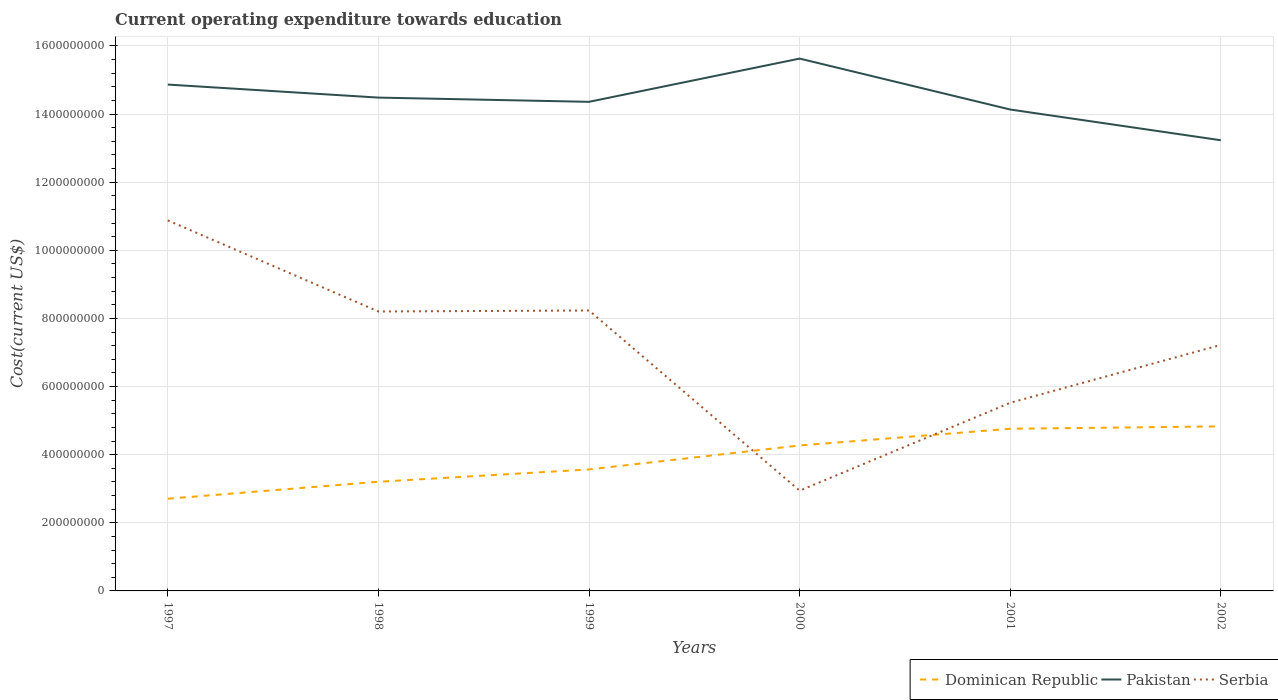Across all years, what is the maximum expenditure towards education in Serbia?
Ensure brevity in your answer.  2.94e+08. What is the total expenditure towards education in Pakistan in the graph?
Make the answer very short. 2.40e+08. What is the difference between the highest and the second highest expenditure towards education in Pakistan?
Make the answer very short. 2.40e+08. Is the expenditure towards education in Pakistan strictly greater than the expenditure towards education in Dominican Republic over the years?
Keep it short and to the point. No. How many years are there in the graph?
Give a very brief answer. 6. What is the difference between two consecutive major ticks on the Y-axis?
Keep it short and to the point. 2.00e+08. Are the values on the major ticks of Y-axis written in scientific E-notation?
Your answer should be very brief. No. Does the graph contain any zero values?
Offer a terse response. No. Does the graph contain grids?
Your answer should be compact. Yes. What is the title of the graph?
Your answer should be very brief. Current operating expenditure towards education. What is the label or title of the X-axis?
Offer a terse response. Years. What is the label or title of the Y-axis?
Offer a very short reply. Cost(current US$). What is the Cost(current US$) of Dominican Republic in 1997?
Make the answer very short. 2.71e+08. What is the Cost(current US$) of Pakistan in 1997?
Keep it short and to the point. 1.49e+09. What is the Cost(current US$) of Serbia in 1997?
Give a very brief answer. 1.09e+09. What is the Cost(current US$) in Dominican Republic in 1998?
Make the answer very short. 3.20e+08. What is the Cost(current US$) of Pakistan in 1998?
Offer a very short reply. 1.45e+09. What is the Cost(current US$) in Serbia in 1998?
Ensure brevity in your answer.  8.20e+08. What is the Cost(current US$) in Dominican Republic in 1999?
Ensure brevity in your answer.  3.57e+08. What is the Cost(current US$) in Pakistan in 1999?
Keep it short and to the point. 1.44e+09. What is the Cost(current US$) in Serbia in 1999?
Offer a very short reply. 8.23e+08. What is the Cost(current US$) of Dominican Republic in 2000?
Give a very brief answer. 4.27e+08. What is the Cost(current US$) in Pakistan in 2000?
Ensure brevity in your answer.  1.56e+09. What is the Cost(current US$) in Serbia in 2000?
Offer a terse response. 2.94e+08. What is the Cost(current US$) of Dominican Republic in 2001?
Provide a succinct answer. 4.76e+08. What is the Cost(current US$) in Pakistan in 2001?
Provide a succinct answer. 1.41e+09. What is the Cost(current US$) in Serbia in 2001?
Offer a very short reply. 5.52e+08. What is the Cost(current US$) in Dominican Republic in 2002?
Make the answer very short. 4.83e+08. What is the Cost(current US$) of Pakistan in 2002?
Your answer should be compact. 1.32e+09. What is the Cost(current US$) of Serbia in 2002?
Offer a very short reply. 7.22e+08. Across all years, what is the maximum Cost(current US$) of Dominican Republic?
Your answer should be very brief. 4.83e+08. Across all years, what is the maximum Cost(current US$) of Pakistan?
Make the answer very short. 1.56e+09. Across all years, what is the maximum Cost(current US$) of Serbia?
Provide a short and direct response. 1.09e+09. Across all years, what is the minimum Cost(current US$) in Dominican Republic?
Your response must be concise. 2.71e+08. Across all years, what is the minimum Cost(current US$) of Pakistan?
Keep it short and to the point. 1.32e+09. Across all years, what is the minimum Cost(current US$) in Serbia?
Provide a short and direct response. 2.94e+08. What is the total Cost(current US$) in Dominican Republic in the graph?
Provide a short and direct response. 2.33e+09. What is the total Cost(current US$) in Pakistan in the graph?
Offer a terse response. 8.67e+09. What is the total Cost(current US$) in Serbia in the graph?
Offer a very short reply. 4.30e+09. What is the difference between the Cost(current US$) in Dominican Republic in 1997 and that in 1998?
Your response must be concise. -4.98e+07. What is the difference between the Cost(current US$) in Pakistan in 1997 and that in 1998?
Give a very brief answer. 3.82e+07. What is the difference between the Cost(current US$) of Serbia in 1997 and that in 1998?
Give a very brief answer. 2.67e+08. What is the difference between the Cost(current US$) of Dominican Republic in 1997 and that in 1999?
Your answer should be very brief. -8.59e+07. What is the difference between the Cost(current US$) in Pakistan in 1997 and that in 1999?
Provide a short and direct response. 5.07e+07. What is the difference between the Cost(current US$) in Serbia in 1997 and that in 1999?
Your answer should be very brief. 2.64e+08. What is the difference between the Cost(current US$) of Dominican Republic in 1997 and that in 2000?
Your answer should be compact. -1.56e+08. What is the difference between the Cost(current US$) of Pakistan in 1997 and that in 2000?
Offer a terse response. -7.63e+07. What is the difference between the Cost(current US$) of Serbia in 1997 and that in 2000?
Offer a terse response. 7.93e+08. What is the difference between the Cost(current US$) in Dominican Republic in 1997 and that in 2001?
Your answer should be very brief. -2.05e+08. What is the difference between the Cost(current US$) of Pakistan in 1997 and that in 2001?
Offer a terse response. 7.33e+07. What is the difference between the Cost(current US$) of Serbia in 1997 and that in 2001?
Ensure brevity in your answer.  5.35e+08. What is the difference between the Cost(current US$) of Dominican Republic in 1997 and that in 2002?
Offer a very short reply. -2.12e+08. What is the difference between the Cost(current US$) in Pakistan in 1997 and that in 2002?
Ensure brevity in your answer.  1.63e+08. What is the difference between the Cost(current US$) of Serbia in 1997 and that in 2002?
Your answer should be very brief. 3.66e+08. What is the difference between the Cost(current US$) of Dominican Republic in 1998 and that in 1999?
Make the answer very short. -3.62e+07. What is the difference between the Cost(current US$) of Pakistan in 1998 and that in 1999?
Make the answer very short. 1.24e+07. What is the difference between the Cost(current US$) in Serbia in 1998 and that in 1999?
Offer a very short reply. -3.01e+06. What is the difference between the Cost(current US$) of Dominican Republic in 1998 and that in 2000?
Offer a very short reply. -1.07e+08. What is the difference between the Cost(current US$) of Pakistan in 1998 and that in 2000?
Your answer should be very brief. -1.15e+08. What is the difference between the Cost(current US$) of Serbia in 1998 and that in 2000?
Ensure brevity in your answer.  5.26e+08. What is the difference between the Cost(current US$) of Dominican Republic in 1998 and that in 2001?
Your answer should be compact. -1.56e+08. What is the difference between the Cost(current US$) in Pakistan in 1998 and that in 2001?
Offer a very short reply. 3.50e+07. What is the difference between the Cost(current US$) in Serbia in 1998 and that in 2001?
Your answer should be compact. 2.68e+08. What is the difference between the Cost(current US$) of Dominican Republic in 1998 and that in 2002?
Ensure brevity in your answer.  -1.63e+08. What is the difference between the Cost(current US$) in Pakistan in 1998 and that in 2002?
Give a very brief answer. 1.25e+08. What is the difference between the Cost(current US$) in Serbia in 1998 and that in 2002?
Your answer should be compact. 9.81e+07. What is the difference between the Cost(current US$) in Dominican Republic in 1999 and that in 2000?
Give a very brief answer. -7.03e+07. What is the difference between the Cost(current US$) in Pakistan in 1999 and that in 2000?
Offer a terse response. -1.27e+08. What is the difference between the Cost(current US$) in Serbia in 1999 and that in 2000?
Your answer should be very brief. 5.29e+08. What is the difference between the Cost(current US$) in Dominican Republic in 1999 and that in 2001?
Your response must be concise. -1.19e+08. What is the difference between the Cost(current US$) in Pakistan in 1999 and that in 2001?
Ensure brevity in your answer.  2.26e+07. What is the difference between the Cost(current US$) of Serbia in 1999 and that in 2001?
Make the answer very short. 2.71e+08. What is the difference between the Cost(current US$) of Dominican Republic in 1999 and that in 2002?
Offer a terse response. -1.26e+08. What is the difference between the Cost(current US$) in Pakistan in 1999 and that in 2002?
Make the answer very short. 1.13e+08. What is the difference between the Cost(current US$) in Serbia in 1999 and that in 2002?
Offer a very short reply. 1.01e+08. What is the difference between the Cost(current US$) of Dominican Republic in 2000 and that in 2001?
Give a very brief answer. -4.91e+07. What is the difference between the Cost(current US$) of Pakistan in 2000 and that in 2001?
Provide a short and direct response. 1.50e+08. What is the difference between the Cost(current US$) in Serbia in 2000 and that in 2001?
Keep it short and to the point. -2.58e+08. What is the difference between the Cost(current US$) of Dominican Republic in 2000 and that in 2002?
Offer a terse response. -5.60e+07. What is the difference between the Cost(current US$) of Pakistan in 2000 and that in 2002?
Provide a short and direct response. 2.40e+08. What is the difference between the Cost(current US$) in Serbia in 2000 and that in 2002?
Your answer should be compact. -4.28e+08. What is the difference between the Cost(current US$) of Dominican Republic in 2001 and that in 2002?
Provide a succinct answer. -6.89e+06. What is the difference between the Cost(current US$) in Pakistan in 2001 and that in 2002?
Your response must be concise. 9.02e+07. What is the difference between the Cost(current US$) of Serbia in 2001 and that in 2002?
Make the answer very short. -1.70e+08. What is the difference between the Cost(current US$) in Dominican Republic in 1997 and the Cost(current US$) in Pakistan in 1998?
Your answer should be very brief. -1.18e+09. What is the difference between the Cost(current US$) in Dominican Republic in 1997 and the Cost(current US$) in Serbia in 1998?
Your answer should be compact. -5.50e+08. What is the difference between the Cost(current US$) in Pakistan in 1997 and the Cost(current US$) in Serbia in 1998?
Your answer should be compact. 6.66e+08. What is the difference between the Cost(current US$) of Dominican Republic in 1997 and the Cost(current US$) of Pakistan in 1999?
Ensure brevity in your answer.  -1.17e+09. What is the difference between the Cost(current US$) in Dominican Republic in 1997 and the Cost(current US$) in Serbia in 1999?
Give a very brief answer. -5.53e+08. What is the difference between the Cost(current US$) of Pakistan in 1997 and the Cost(current US$) of Serbia in 1999?
Your response must be concise. 6.63e+08. What is the difference between the Cost(current US$) in Dominican Republic in 1997 and the Cost(current US$) in Pakistan in 2000?
Offer a very short reply. -1.29e+09. What is the difference between the Cost(current US$) of Dominican Republic in 1997 and the Cost(current US$) of Serbia in 2000?
Provide a succinct answer. -2.36e+07. What is the difference between the Cost(current US$) in Pakistan in 1997 and the Cost(current US$) in Serbia in 2000?
Make the answer very short. 1.19e+09. What is the difference between the Cost(current US$) of Dominican Republic in 1997 and the Cost(current US$) of Pakistan in 2001?
Give a very brief answer. -1.14e+09. What is the difference between the Cost(current US$) in Dominican Republic in 1997 and the Cost(current US$) in Serbia in 2001?
Make the answer very short. -2.82e+08. What is the difference between the Cost(current US$) of Pakistan in 1997 and the Cost(current US$) of Serbia in 2001?
Give a very brief answer. 9.34e+08. What is the difference between the Cost(current US$) of Dominican Republic in 1997 and the Cost(current US$) of Pakistan in 2002?
Offer a very short reply. -1.05e+09. What is the difference between the Cost(current US$) of Dominican Republic in 1997 and the Cost(current US$) of Serbia in 2002?
Ensure brevity in your answer.  -4.51e+08. What is the difference between the Cost(current US$) in Pakistan in 1997 and the Cost(current US$) in Serbia in 2002?
Offer a very short reply. 7.64e+08. What is the difference between the Cost(current US$) of Dominican Republic in 1998 and the Cost(current US$) of Pakistan in 1999?
Your answer should be very brief. -1.12e+09. What is the difference between the Cost(current US$) in Dominican Republic in 1998 and the Cost(current US$) in Serbia in 1999?
Your answer should be compact. -5.03e+08. What is the difference between the Cost(current US$) of Pakistan in 1998 and the Cost(current US$) of Serbia in 1999?
Ensure brevity in your answer.  6.25e+08. What is the difference between the Cost(current US$) in Dominican Republic in 1998 and the Cost(current US$) in Pakistan in 2000?
Give a very brief answer. -1.24e+09. What is the difference between the Cost(current US$) of Dominican Republic in 1998 and the Cost(current US$) of Serbia in 2000?
Offer a terse response. 2.61e+07. What is the difference between the Cost(current US$) in Pakistan in 1998 and the Cost(current US$) in Serbia in 2000?
Give a very brief answer. 1.15e+09. What is the difference between the Cost(current US$) in Dominican Republic in 1998 and the Cost(current US$) in Pakistan in 2001?
Offer a very short reply. -1.09e+09. What is the difference between the Cost(current US$) of Dominican Republic in 1998 and the Cost(current US$) of Serbia in 2001?
Keep it short and to the point. -2.32e+08. What is the difference between the Cost(current US$) of Pakistan in 1998 and the Cost(current US$) of Serbia in 2001?
Your answer should be very brief. 8.96e+08. What is the difference between the Cost(current US$) of Dominican Republic in 1998 and the Cost(current US$) of Pakistan in 2002?
Provide a short and direct response. -1.00e+09. What is the difference between the Cost(current US$) of Dominican Republic in 1998 and the Cost(current US$) of Serbia in 2002?
Your answer should be very brief. -4.02e+08. What is the difference between the Cost(current US$) in Pakistan in 1998 and the Cost(current US$) in Serbia in 2002?
Your answer should be very brief. 7.26e+08. What is the difference between the Cost(current US$) of Dominican Republic in 1999 and the Cost(current US$) of Pakistan in 2000?
Provide a short and direct response. -1.21e+09. What is the difference between the Cost(current US$) of Dominican Republic in 1999 and the Cost(current US$) of Serbia in 2000?
Keep it short and to the point. 6.23e+07. What is the difference between the Cost(current US$) of Pakistan in 1999 and the Cost(current US$) of Serbia in 2000?
Provide a succinct answer. 1.14e+09. What is the difference between the Cost(current US$) in Dominican Republic in 1999 and the Cost(current US$) in Pakistan in 2001?
Offer a terse response. -1.06e+09. What is the difference between the Cost(current US$) in Dominican Republic in 1999 and the Cost(current US$) in Serbia in 2001?
Ensure brevity in your answer.  -1.96e+08. What is the difference between the Cost(current US$) in Pakistan in 1999 and the Cost(current US$) in Serbia in 2001?
Your response must be concise. 8.84e+08. What is the difference between the Cost(current US$) of Dominican Republic in 1999 and the Cost(current US$) of Pakistan in 2002?
Your answer should be compact. -9.66e+08. What is the difference between the Cost(current US$) of Dominican Republic in 1999 and the Cost(current US$) of Serbia in 2002?
Your answer should be compact. -3.66e+08. What is the difference between the Cost(current US$) in Pakistan in 1999 and the Cost(current US$) in Serbia in 2002?
Offer a terse response. 7.14e+08. What is the difference between the Cost(current US$) in Dominican Republic in 2000 and the Cost(current US$) in Pakistan in 2001?
Give a very brief answer. -9.86e+08. What is the difference between the Cost(current US$) of Dominican Republic in 2000 and the Cost(current US$) of Serbia in 2001?
Provide a short and direct response. -1.25e+08. What is the difference between the Cost(current US$) of Pakistan in 2000 and the Cost(current US$) of Serbia in 2001?
Make the answer very short. 1.01e+09. What is the difference between the Cost(current US$) of Dominican Republic in 2000 and the Cost(current US$) of Pakistan in 2002?
Your answer should be very brief. -8.96e+08. What is the difference between the Cost(current US$) of Dominican Republic in 2000 and the Cost(current US$) of Serbia in 2002?
Your answer should be compact. -2.95e+08. What is the difference between the Cost(current US$) of Pakistan in 2000 and the Cost(current US$) of Serbia in 2002?
Provide a short and direct response. 8.41e+08. What is the difference between the Cost(current US$) of Dominican Republic in 2001 and the Cost(current US$) of Pakistan in 2002?
Your answer should be very brief. -8.47e+08. What is the difference between the Cost(current US$) of Dominican Republic in 2001 and the Cost(current US$) of Serbia in 2002?
Make the answer very short. -2.46e+08. What is the difference between the Cost(current US$) of Pakistan in 2001 and the Cost(current US$) of Serbia in 2002?
Your response must be concise. 6.91e+08. What is the average Cost(current US$) of Dominican Republic per year?
Give a very brief answer. 3.89e+08. What is the average Cost(current US$) in Pakistan per year?
Keep it short and to the point. 1.44e+09. What is the average Cost(current US$) in Serbia per year?
Provide a short and direct response. 7.17e+08. In the year 1997, what is the difference between the Cost(current US$) in Dominican Republic and Cost(current US$) in Pakistan?
Give a very brief answer. -1.22e+09. In the year 1997, what is the difference between the Cost(current US$) in Dominican Republic and Cost(current US$) in Serbia?
Provide a succinct answer. -8.17e+08. In the year 1997, what is the difference between the Cost(current US$) of Pakistan and Cost(current US$) of Serbia?
Keep it short and to the point. 3.99e+08. In the year 1998, what is the difference between the Cost(current US$) of Dominican Republic and Cost(current US$) of Pakistan?
Your response must be concise. -1.13e+09. In the year 1998, what is the difference between the Cost(current US$) of Dominican Republic and Cost(current US$) of Serbia?
Your answer should be very brief. -5.00e+08. In the year 1998, what is the difference between the Cost(current US$) in Pakistan and Cost(current US$) in Serbia?
Make the answer very short. 6.28e+08. In the year 1999, what is the difference between the Cost(current US$) of Dominican Republic and Cost(current US$) of Pakistan?
Make the answer very short. -1.08e+09. In the year 1999, what is the difference between the Cost(current US$) in Dominican Republic and Cost(current US$) in Serbia?
Your response must be concise. -4.67e+08. In the year 1999, what is the difference between the Cost(current US$) in Pakistan and Cost(current US$) in Serbia?
Make the answer very short. 6.13e+08. In the year 2000, what is the difference between the Cost(current US$) of Dominican Republic and Cost(current US$) of Pakistan?
Make the answer very short. -1.14e+09. In the year 2000, what is the difference between the Cost(current US$) in Dominican Republic and Cost(current US$) in Serbia?
Offer a terse response. 1.33e+08. In the year 2000, what is the difference between the Cost(current US$) of Pakistan and Cost(current US$) of Serbia?
Your answer should be compact. 1.27e+09. In the year 2001, what is the difference between the Cost(current US$) in Dominican Republic and Cost(current US$) in Pakistan?
Offer a very short reply. -9.37e+08. In the year 2001, what is the difference between the Cost(current US$) of Dominican Republic and Cost(current US$) of Serbia?
Offer a very short reply. -7.62e+07. In the year 2001, what is the difference between the Cost(current US$) in Pakistan and Cost(current US$) in Serbia?
Provide a succinct answer. 8.61e+08. In the year 2002, what is the difference between the Cost(current US$) of Dominican Republic and Cost(current US$) of Pakistan?
Give a very brief answer. -8.40e+08. In the year 2002, what is the difference between the Cost(current US$) of Dominican Republic and Cost(current US$) of Serbia?
Make the answer very short. -2.39e+08. In the year 2002, what is the difference between the Cost(current US$) of Pakistan and Cost(current US$) of Serbia?
Ensure brevity in your answer.  6.01e+08. What is the ratio of the Cost(current US$) of Dominican Republic in 1997 to that in 1998?
Give a very brief answer. 0.84. What is the ratio of the Cost(current US$) of Pakistan in 1997 to that in 1998?
Offer a terse response. 1.03. What is the ratio of the Cost(current US$) in Serbia in 1997 to that in 1998?
Offer a terse response. 1.33. What is the ratio of the Cost(current US$) of Dominican Republic in 1997 to that in 1999?
Offer a very short reply. 0.76. What is the ratio of the Cost(current US$) of Pakistan in 1997 to that in 1999?
Your answer should be very brief. 1.04. What is the ratio of the Cost(current US$) of Serbia in 1997 to that in 1999?
Your response must be concise. 1.32. What is the ratio of the Cost(current US$) of Dominican Republic in 1997 to that in 2000?
Make the answer very short. 0.63. What is the ratio of the Cost(current US$) in Pakistan in 1997 to that in 2000?
Offer a very short reply. 0.95. What is the ratio of the Cost(current US$) in Serbia in 1997 to that in 2000?
Provide a short and direct response. 3.7. What is the ratio of the Cost(current US$) in Dominican Republic in 1997 to that in 2001?
Your answer should be very brief. 0.57. What is the ratio of the Cost(current US$) of Pakistan in 1997 to that in 2001?
Keep it short and to the point. 1.05. What is the ratio of the Cost(current US$) of Serbia in 1997 to that in 2001?
Give a very brief answer. 1.97. What is the ratio of the Cost(current US$) of Dominican Republic in 1997 to that in 2002?
Give a very brief answer. 0.56. What is the ratio of the Cost(current US$) in Pakistan in 1997 to that in 2002?
Provide a succinct answer. 1.12. What is the ratio of the Cost(current US$) in Serbia in 1997 to that in 2002?
Ensure brevity in your answer.  1.51. What is the ratio of the Cost(current US$) of Dominican Republic in 1998 to that in 1999?
Make the answer very short. 0.9. What is the ratio of the Cost(current US$) in Pakistan in 1998 to that in 1999?
Provide a succinct answer. 1.01. What is the ratio of the Cost(current US$) of Dominican Republic in 1998 to that in 2000?
Your answer should be compact. 0.75. What is the ratio of the Cost(current US$) of Pakistan in 1998 to that in 2000?
Your answer should be very brief. 0.93. What is the ratio of the Cost(current US$) of Serbia in 1998 to that in 2000?
Give a very brief answer. 2.79. What is the ratio of the Cost(current US$) of Dominican Republic in 1998 to that in 2001?
Keep it short and to the point. 0.67. What is the ratio of the Cost(current US$) in Pakistan in 1998 to that in 2001?
Your response must be concise. 1.02. What is the ratio of the Cost(current US$) of Serbia in 1998 to that in 2001?
Ensure brevity in your answer.  1.49. What is the ratio of the Cost(current US$) in Dominican Republic in 1998 to that in 2002?
Your answer should be very brief. 0.66. What is the ratio of the Cost(current US$) of Pakistan in 1998 to that in 2002?
Offer a terse response. 1.09. What is the ratio of the Cost(current US$) of Serbia in 1998 to that in 2002?
Provide a succinct answer. 1.14. What is the ratio of the Cost(current US$) in Dominican Republic in 1999 to that in 2000?
Your answer should be very brief. 0.84. What is the ratio of the Cost(current US$) of Pakistan in 1999 to that in 2000?
Provide a short and direct response. 0.92. What is the ratio of the Cost(current US$) of Serbia in 1999 to that in 2000?
Ensure brevity in your answer.  2.8. What is the ratio of the Cost(current US$) of Dominican Republic in 1999 to that in 2001?
Give a very brief answer. 0.75. What is the ratio of the Cost(current US$) in Serbia in 1999 to that in 2001?
Your answer should be very brief. 1.49. What is the ratio of the Cost(current US$) in Dominican Republic in 1999 to that in 2002?
Give a very brief answer. 0.74. What is the ratio of the Cost(current US$) in Pakistan in 1999 to that in 2002?
Provide a short and direct response. 1.09. What is the ratio of the Cost(current US$) in Serbia in 1999 to that in 2002?
Provide a succinct answer. 1.14. What is the ratio of the Cost(current US$) in Dominican Republic in 2000 to that in 2001?
Give a very brief answer. 0.9. What is the ratio of the Cost(current US$) in Pakistan in 2000 to that in 2001?
Offer a very short reply. 1.11. What is the ratio of the Cost(current US$) in Serbia in 2000 to that in 2001?
Your answer should be very brief. 0.53. What is the ratio of the Cost(current US$) in Dominican Republic in 2000 to that in 2002?
Offer a terse response. 0.88. What is the ratio of the Cost(current US$) in Pakistan in 2000 to that in 2002?
Make the answer very short. 1.18. What is the ratio of the Cost(current US$) of Serbia in 2000 to that in 2002?
Provide a short and direct response. 0.41. What is the ratio of the Cost(current US$) of Dominican Republic in 2001 to that in 2002?
Offer a very short reply. 0.99. What is the ratio of the Cost(current US$) of Pakistan in 2001 to that in 2002?
Ensure brevity in your answer.  1.07. What is the ratio of the Cost(current US$) in Serbia in 2001 to that in 2002?
Ensure brevity in your answer.  0.76. What is the difference between the highest and the second highest Cost(current US$) in Dominican Republic?
Your answer should be very brief. 6.89e+06. What is the difference between the highest and the second highest Cost(current US$) in Pakistan?
Your answer should be very brief. 7.63e+07. What is the difference between the highest and the second highest Cost(current US$) in Serbia?
Make the answer very short. 2.64e+08. What is the difference between the highest and the lowest Cost(current US$) of Dominican Republic?
Ensure brevity in your answer.  2.12e+08. What is the difference between the highest and the lowest Cost(current US$) of Pakistan?
Your answer should be very brief. 2.40e+08. What is the difference between the highest and the lowest Cost(current US$) of Serbia?
Offer a terse response. 7.93e+08. 